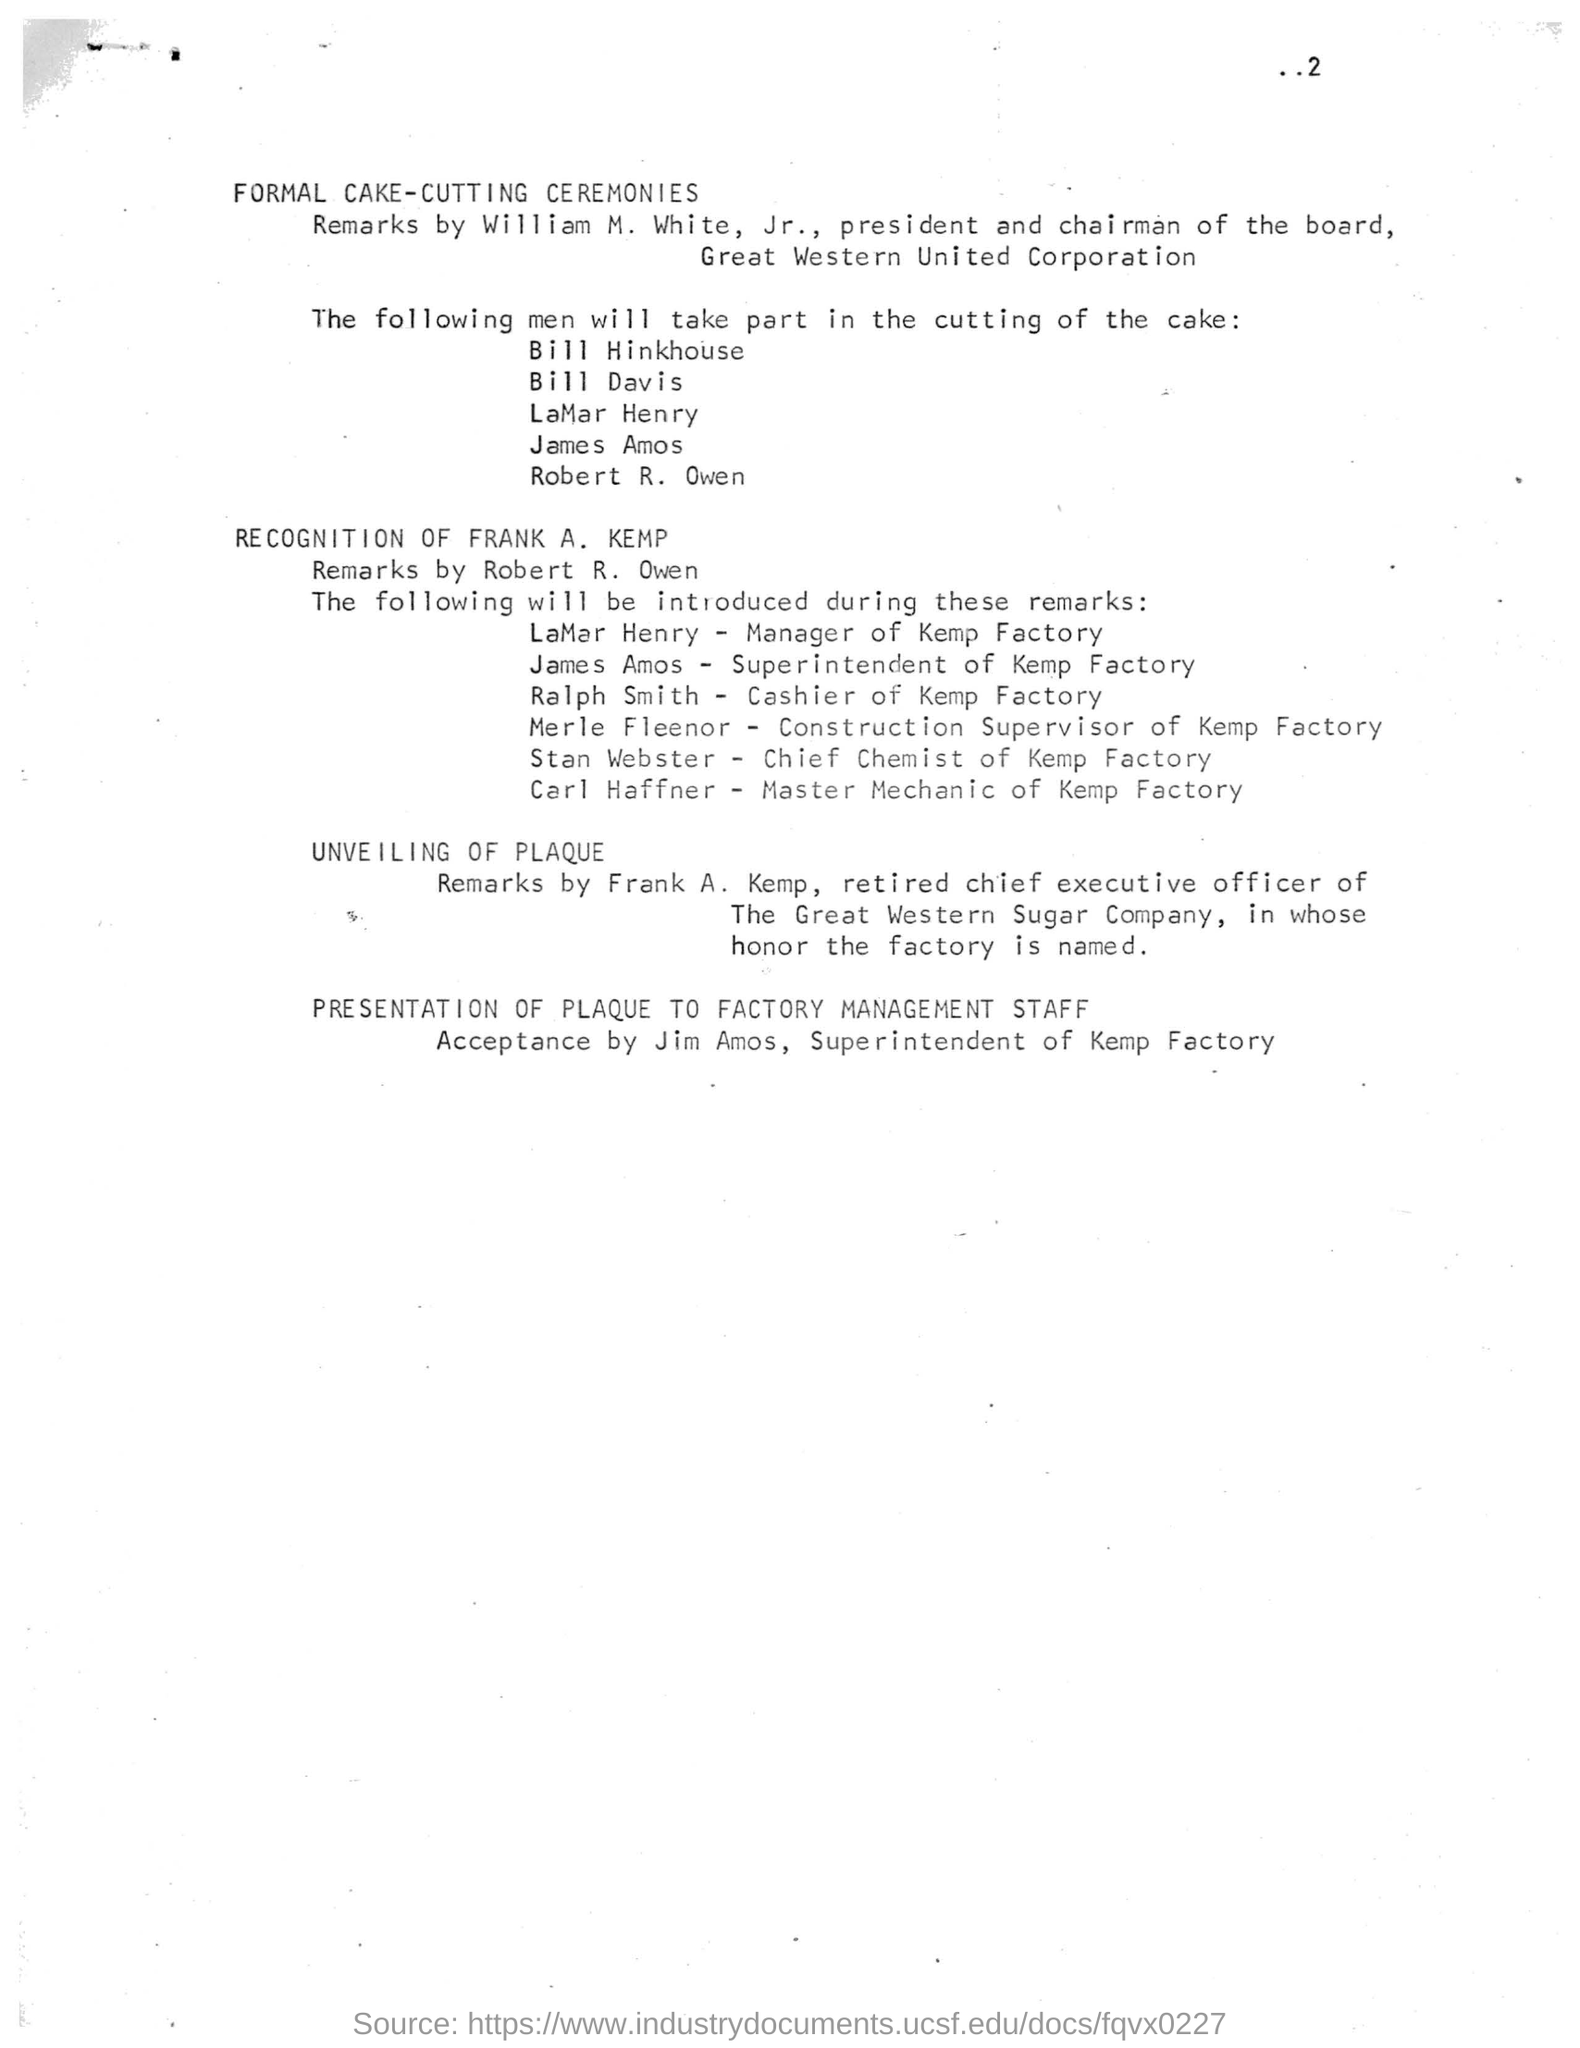In whose honor is the factory named?
Keep it short and to the point. FRANK A. KEMP. Who is the president and chairman of the board in Great Western United Corporation?
Keep it short and to the point. William M. White, Jr. Who is the Chief Chemist of Kemp Factory?
Your answer should be very brief. STAN WEBSTER. Who is the manager of Kemp Factory?
Your answer should be compact. LaMar Henry. 